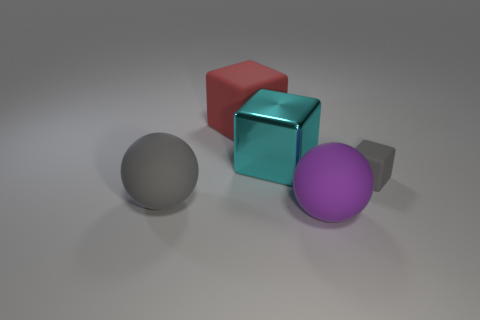Add 3 small blue spheres. How many objects exist? 8 Subtract all blocks. How many objects are left? 2 Add 3 red balls. How many red balls exist? 3 Subtract 1 red cubes. How many objects are left? 4 Subtract all big gray objects. Subtract all gray spheres. How many objects are left? 3 Add 4 gray objects. How many gray objects are left? 6 